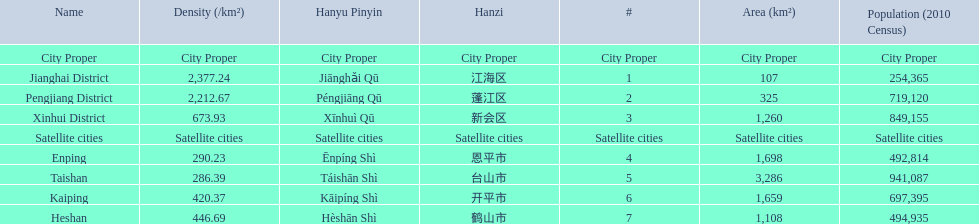Is enping more/less dense than kaiping? Less. 